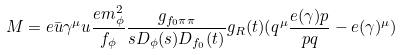<formula> <loc_0><loc_0><loc_500><loc_500>M = e \bar { u } \gamma ^ { \mu } u \frac { e m _ { \phi } ^ { 2 } } { f _ { \phi } } \frac { g _ { f _ { 0 } \pi \pi } } { s D _ { \phi } ( s ) D _ { f _ { 0 } } ( t ) } g _ { R } ( t ) ( q ^ { \mu } \frac { e ( \gamma ) p } { p q } - e ( \gamma ) ^ { \mu } )</formula> 